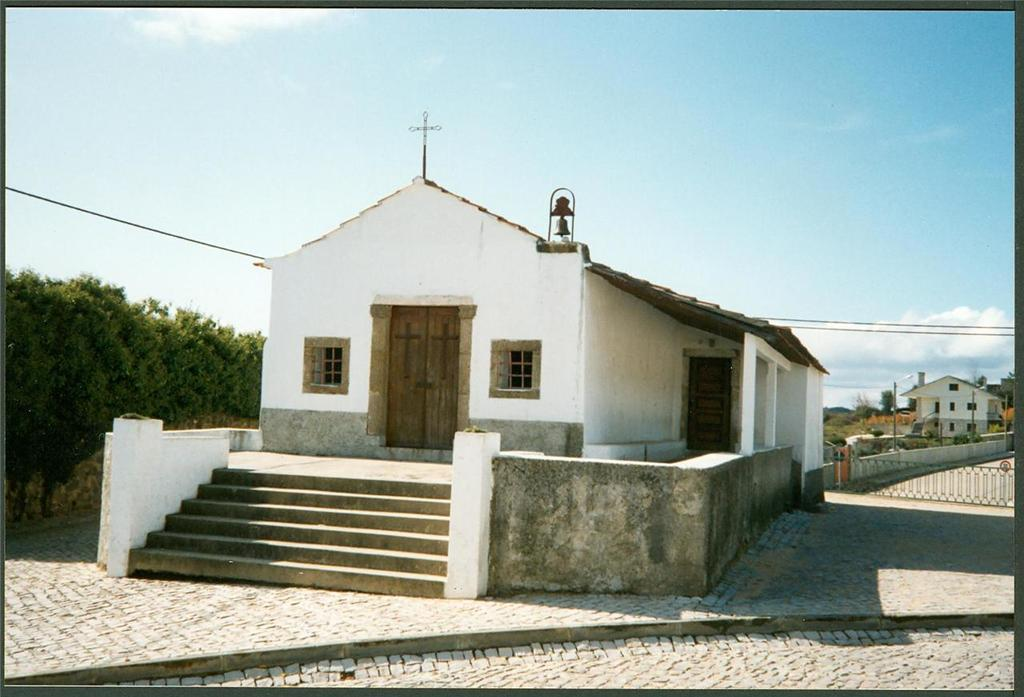What type of building is in the image? There is a church in the image. What is the color of the church? The church is white in color. What features can be seen on the church? The church has windows and a door. What is at the bottom of the image? There is a road at the bottom of the image. What is on the left side of the image? There are trees to the left of the image. What is visible at the top of the image? The sky is visible at the top of the image. What type of quartz can be seen in the image? There is no quartz present in the image. How many balls are visible in the image? There are no balls visible in the image. 